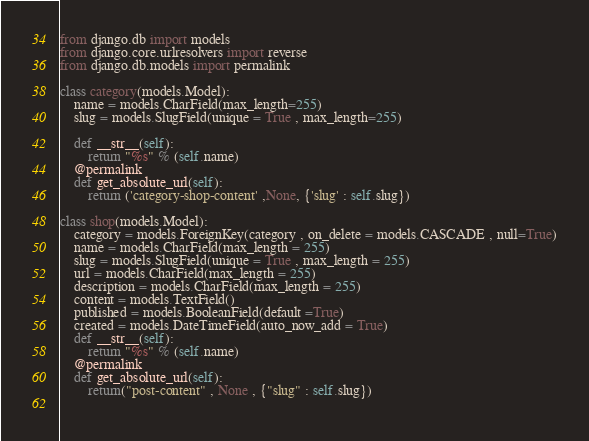Convert code to text. <code><loc_0><loc_0><loc_500><loc_500><_Python_>from django.db import models
from django.core.urlresolvers import reverse
from django.db.models import permalink

class category(models.Model):
    name = models.CharField(max_length=255)
    slug = models.SlugField(unique = True , max_length=255)
    
    def __str__(self):
        return "%s" % (self.name)
    @permalink
    def get_absolute_url(self):
        return ('category-shop-content' ,None, {'slug' : self.slug})
    
class shop(models.Model):
    category = models.ForeignKey(category , on_delete = models.CASCADE , null=True)
    name = models.CharField(max_length = 255)
    slug = models.SlugField(unique = True , max_length = 255)
    url = models.CharField(max_length = 255)
    description = models.CharField(max_length = 255)
    content = models.TextField()
    published = models.BooleanField(default =True)
    created = models.DateTimeField(auto_now_add = True)
    def __str__(self):
        return "%s" % (self.name)
    @permalink
    def get_absolute_url(self):
        return("post-content" , None , {"slug" : self.slug})
    </code> 